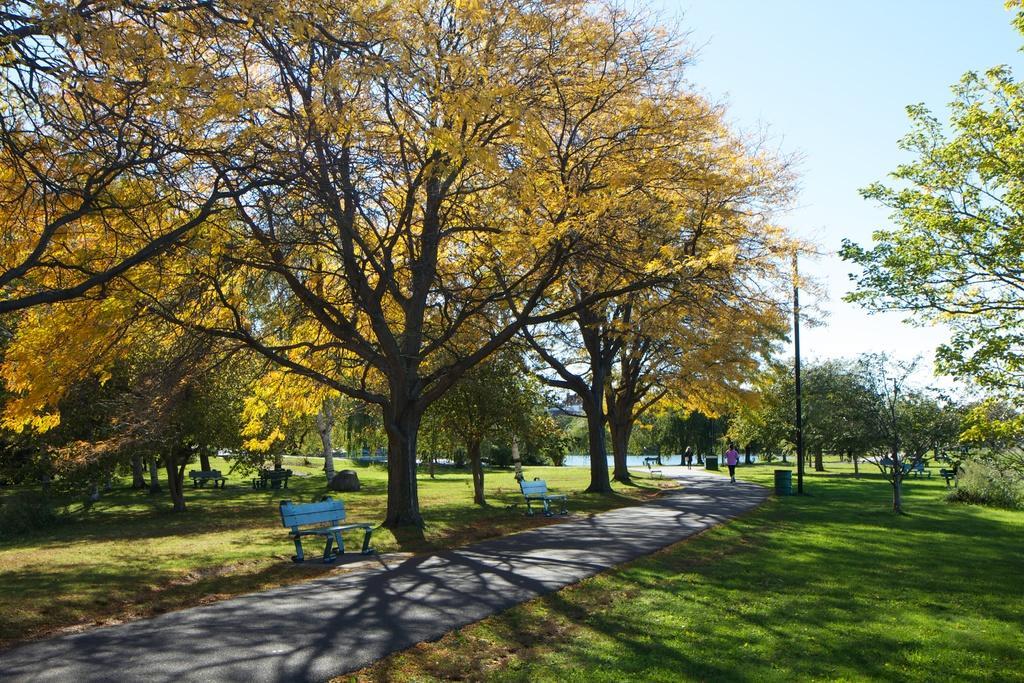How would you summarize this image in a sentence or two? The image might be taken in a park. In the foreground of the picture we can see trees, benches, grass, dustbin, pole, road and other objects. In the middle of the picture we can see a person walking on the road. In the background there is a water body. At the top there is sky. 